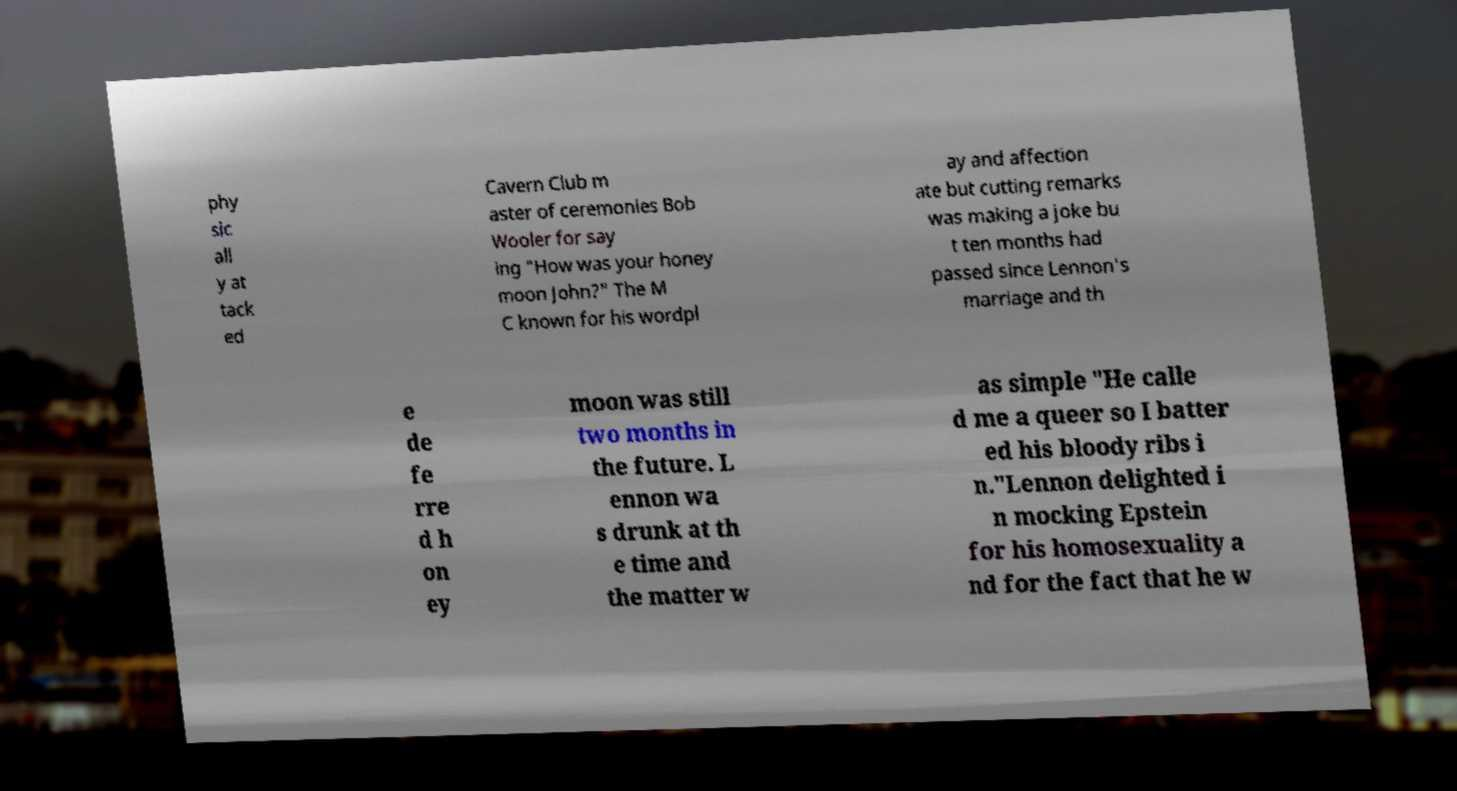For documentation purposes, I need the text within this image transcribed. Could you provide that? phy sic all y at tack ed Cavern Club m aster of ceremonies Bob Wooler for say ing "How was your honey moon John?" The M C known for his wordpl ay and affection ate but cutting remarks was making a joke bu t ten months had passed since Lennon's marriage and th e de fe rre d h on ey moon was still two months in the future. L ennon wa s drunk at th e time and the matter w as simple "He calle d me a queer so I batter ed his bloody ribs i n."Lennon delighted i n mocking Epstein for his homosexuality a nd for the fact that he w 